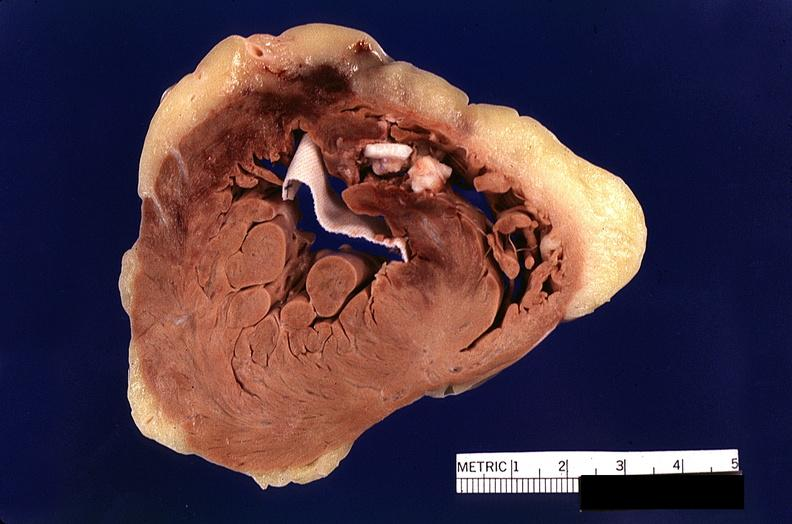s cardiovascular present?
Answer the question using a single word or phrase. Yes 